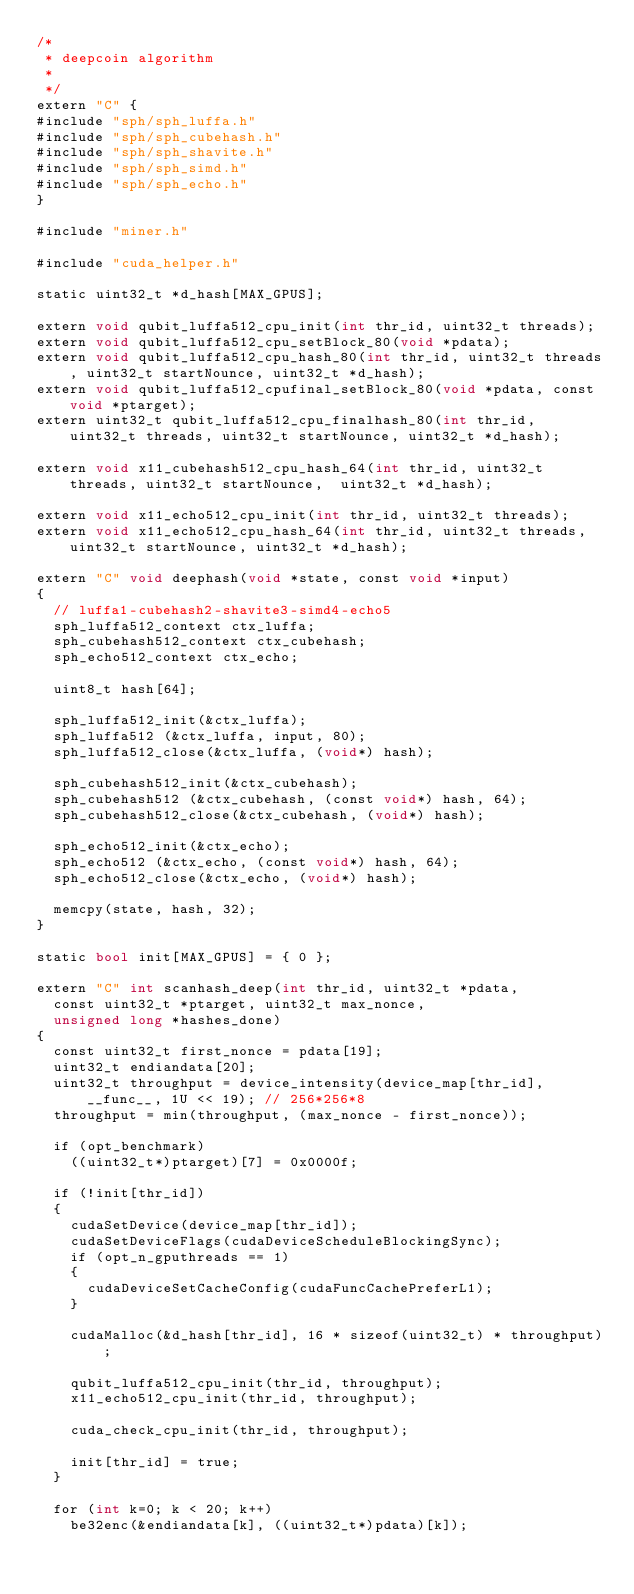Convert code to text. <code><loc_0><loc_0><loc_500><loc_500><_Cuda_>/*
 * deepcoin algorithm
 *
 */
extern "C" {
#include "sph/sph_luffa.h"
#include "sph/sph_cubehash.h"
#include "sph/sph_shavite.h"
#include "sph/sph_simd.h"
#include "sph/sph_echo.h"
}

#include "miner.h"

#include "cuda_helper.h"

static uint32_t *d_hash[MAX_GPUS];

extern void qubit_luffa512_cpu_init(int thr_id, uint32_t threads);
extern void qubit_luffa512_cpu_setBlock_80(void *pdata);
extern void qubit_luffa512_cpu_hash_80(int thr_id, uint32_t threads, uint32_t startNounce, uint32_t *d_hash);
extern void qubit_luffa512_cpufinal_setBlock_80(void *pdata, const void *ptarget);
extern uint32_t qubit_luffa512_cpu_finalhash_80(int thr_id, uint32_t threads, uint32_t startNounce, uint32_t *d_hash);

extern void x11_cubehash512_cpu_hash_64(int thr_id, uint32_t threads, uint32_t startNounce,  uint32_t *d_hash);

extern void x11_echo512_cpu_init(int thr_id, uint32_t threads);
extern void x11_echo512_cpu_hash_64(int thr_id, uint32_t threads, uint32_t startNounce, uint32_t *d_hash);

extern "C" void deephash(void *state, const void *input)
{
	// luffa1-cubehash2-shavite3-simd4-echo5
	sph_luffa512_context ctx_luffa;
	sph_cubehash512_context ctx_cubehash;
	sph_echo512_context ctx_echo;

	uint8_t hash[64];

	sph_luffa512_init(&ctx_luffa);
	sph_luffa512 (&ctx_luffa, input, 80);
	sph_luffa512_close(&ctx_luffa, (void*) hash);

	sph_cubehash512_init(&ctx_cubehash);
	sph_cubehash512 (&ctx_cubehash, (const void*) hash, 64);
	sph_cubehash512_close(&ctx_cubehash, (void*) hash);

	sph_echo512_init(&ctx_echo);
	sph_echo512 (&ctx_echo, (const void*) hash, 64);
	sph_echo512_close(&ctx_echo, (void*) hash);

	memcpy(state, hash, 32);
}

static bool init[MAX_GPUS] = { 0 };

extern "C" int scanhash_deep(int thr_id, uint32_t *pdata,
	const uint32_t *ptarget, uint32_t max_nonce,
	unsigned long *hashes_done)
{
	const uint32_t first_nonce = pdata[19];
	uint32_t endiandata[20];
	uint32_t throughput = device_intensity(device_map[thr_id], __func__, 1U << 19); // 256*256*8
	throughput = min(throughput, (max_nonce - first_nonce));

	if (opt_benchmark)
		((uint32_t*)ptarget)[7] = 0x0000f;

	if (!init[thr_id])
	{
		cudaSetDevice(device_map[thr_id]);
		cudaSetDeviceFlags(cudaDeviceScheduleBlockingSync);
		if (opt_n_gputhreads == 1)
		{
			cudaDeviceSetCacheConfig(cudaFuncCachePreferL1);
		}

		cudaMalloc(&d_hash[thr_id], 16 * sizeof(uint32_t) * throughput);

		qubit_luffa512_cpu_init(thr_id, throughput);
		x11_echo512_cpu_init(thr_id, throughput);

		cuda_check_cpu_init(thr_id, throughput);

		init[thr_id] = true;
	}

	for (int k=0; k < 20; k++)
		be32enc(&endiandata[k], ((uint32_t*)pdata)[k]);
</code> 